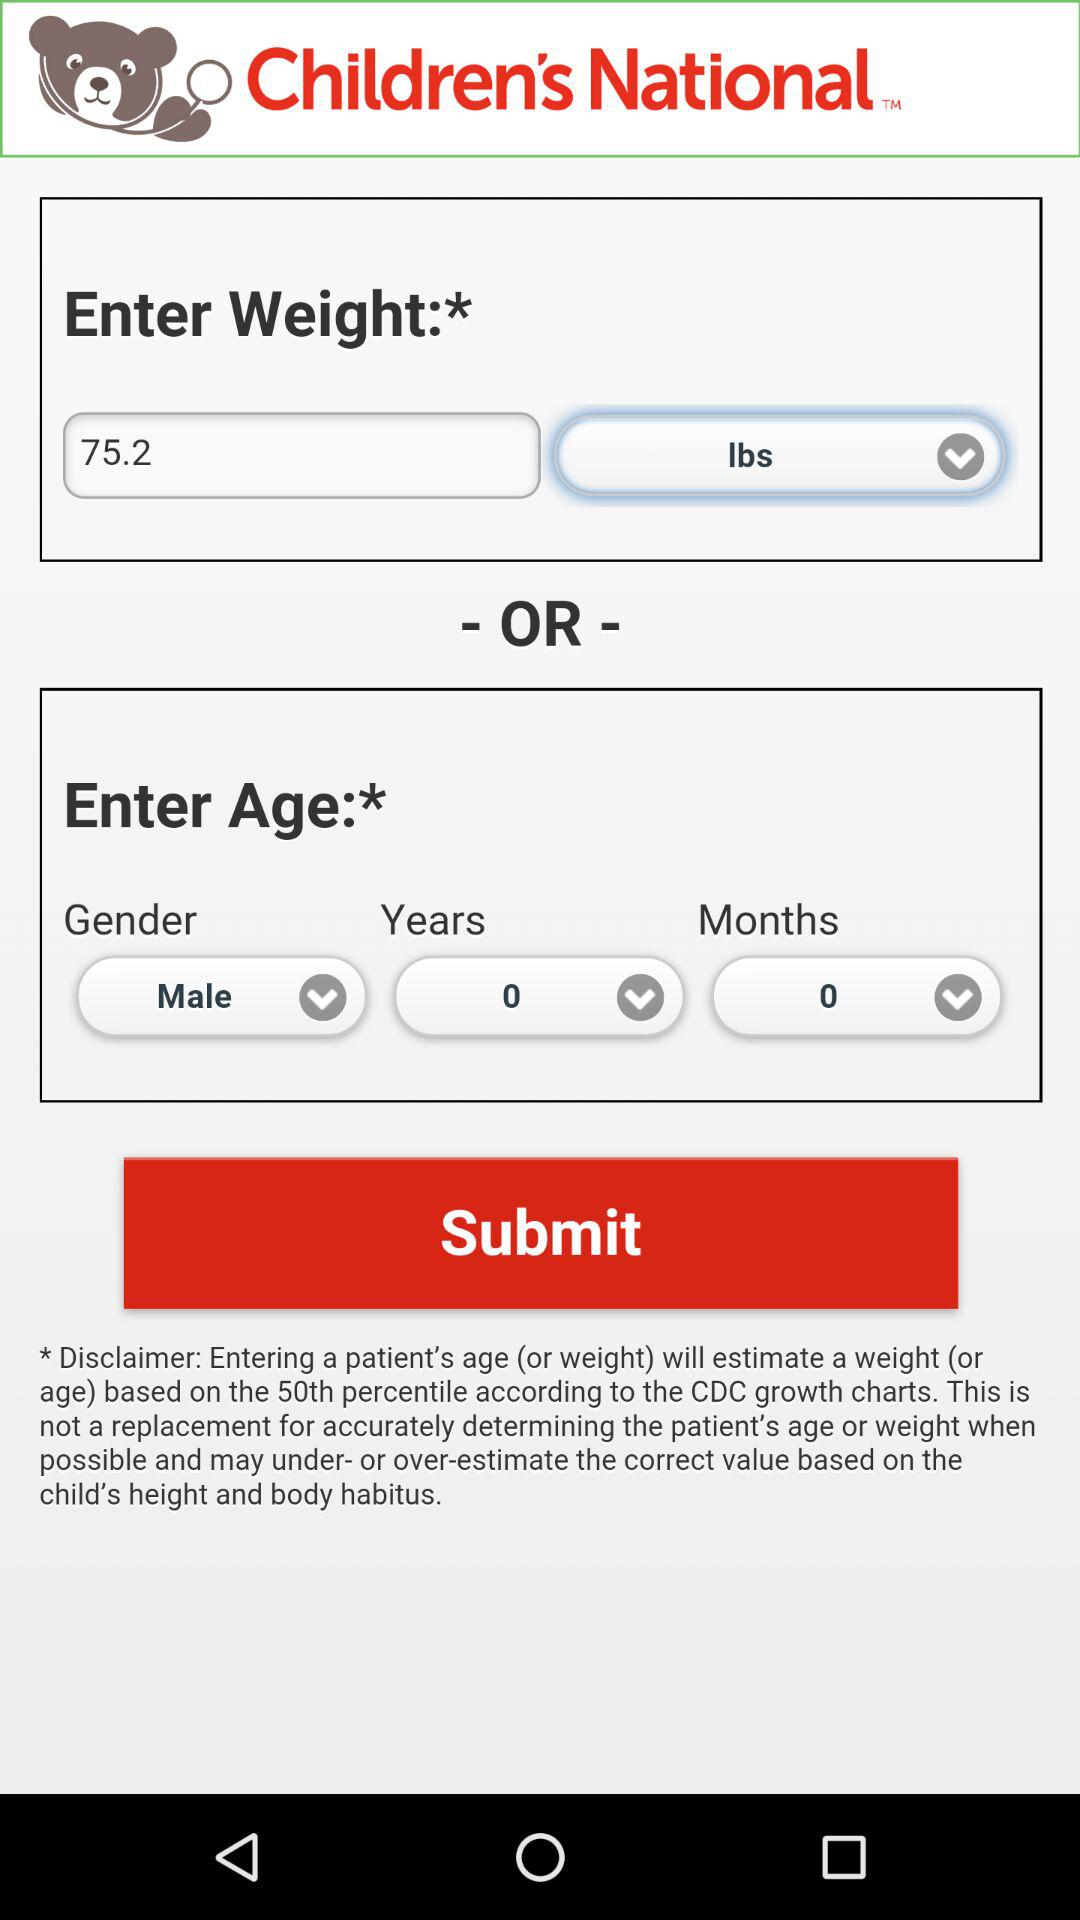What is the gender? The gender is male. 